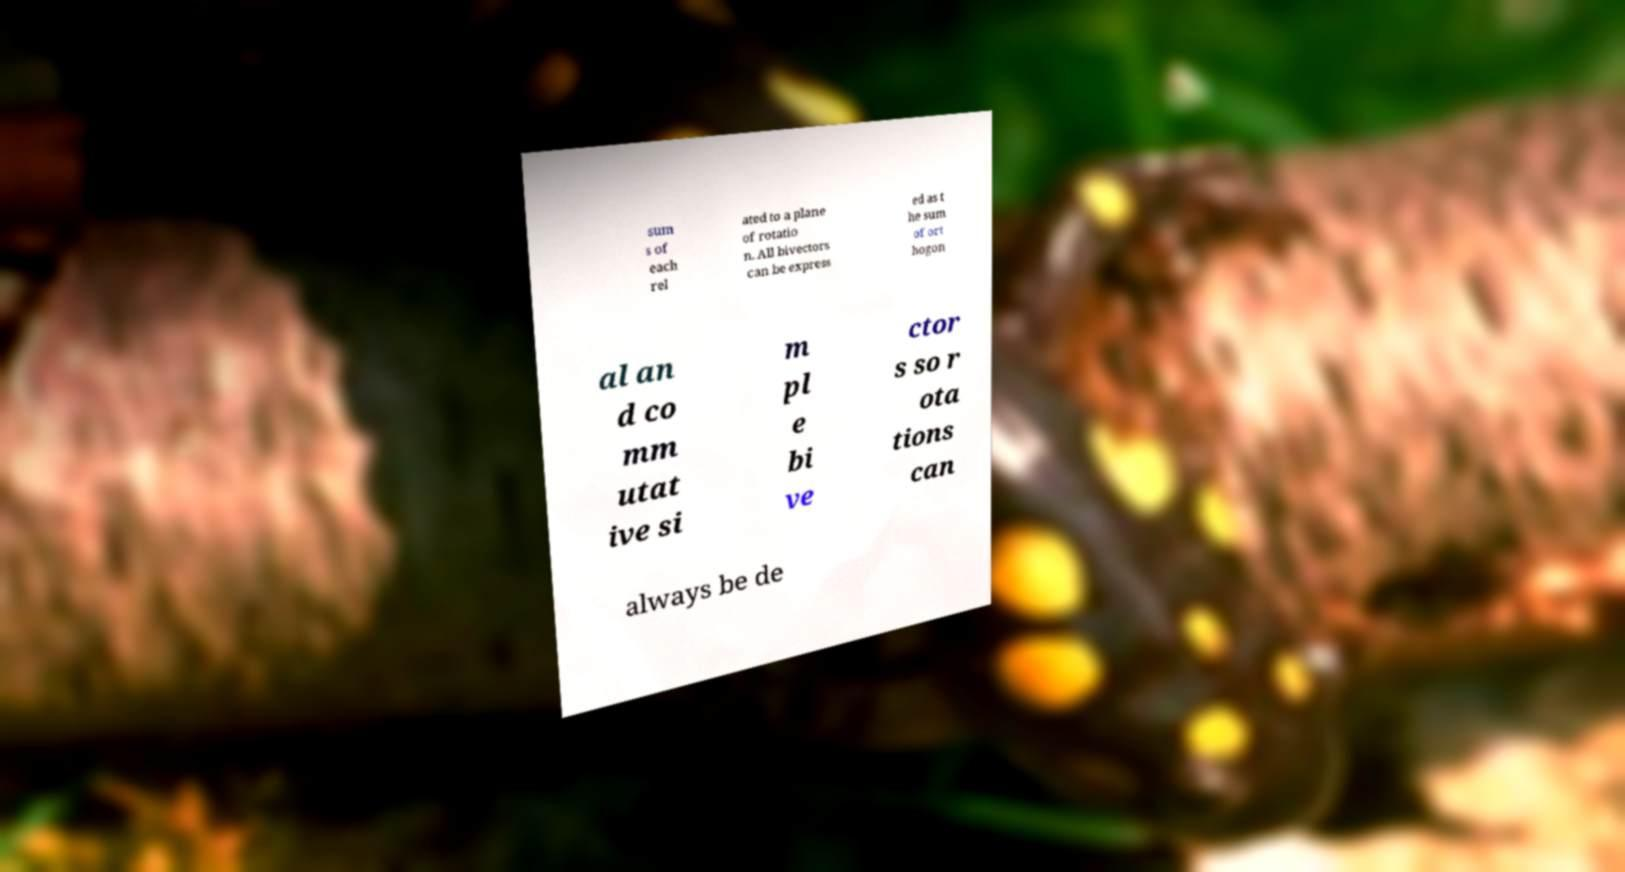Please read and relay the text visible in this image. What does it say? sum s of each rel ated to a plane of rotatio n. All bivectors can be express ed as t he sum of ort hogon al an d co mm utat ive si m pl e bi ve ctor s so r ota tions can always be de 